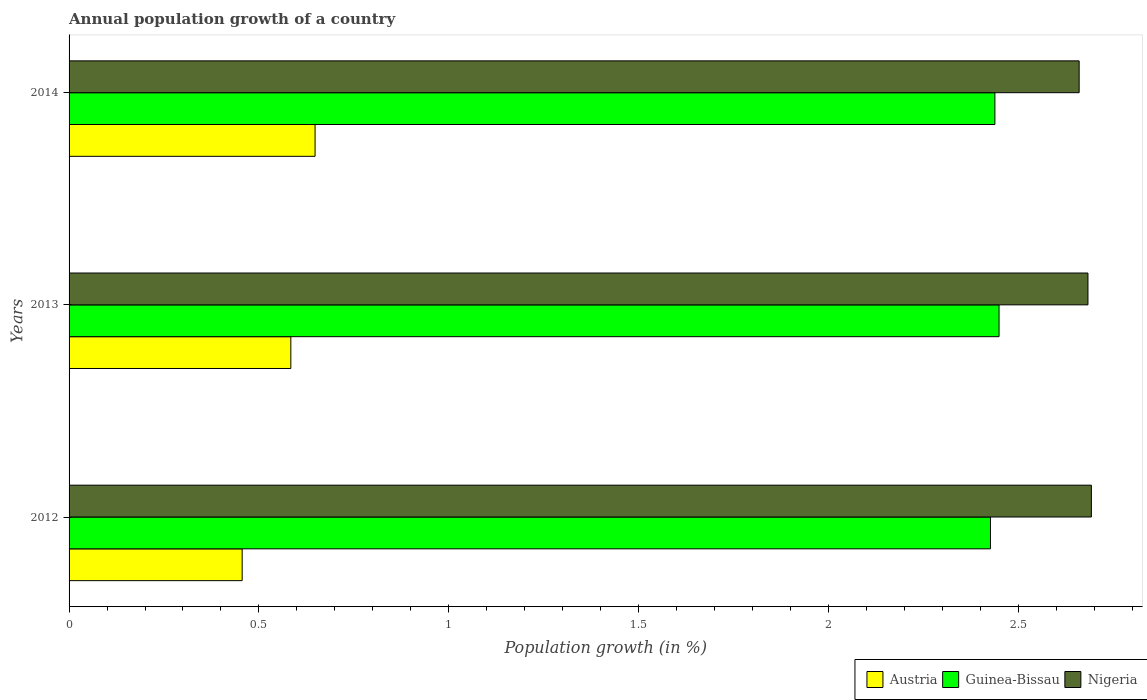How many groups of bars are there?
Keep it short and to the point. 3. In how many cases, is the number of bars for a given year not equal to the number of legend labels?
Provide a short and direct response. 0. What is the annual population growth in Austria in 2012?
Ensure brevity in your answer.  0.46. Across all years, what is the maximum annual population growth in Nigeria?
Offer a very short reply. 2.69. Across all years, what is the minimum annual population growth in Austria?
Your answer should be compact. 0.46. In which year was the annual population growth in Guinea-Bissau minimum?
Your answer should be very brief. 2012. What is the total annual population growth in Guinea-Bissau in the graph?
Your response must be concise. 7.31. What is the difference between the annual population growth in Nigeria in 2012 and that in 2013?
Your answer should be compact. 0.01. What is the difference between the annual population growth in Austria in 2014 and the annual population growth in Guinea-Bissau in 2013?
Provide a short and direct response. -1.8. What is the average annual population growth in Guinea-Bissau per year?
Keep it short and to the point. 2.44. In the year 2012, what is the difference between the annual population growth in Nigeria and annual population growth in Guinea-Bissau?
Offer a very short reply. 0.27. In how many years, is the annual population growth in Nigeria greater than 2.6 %?
Provide a short and direct response. 3. What is the ratio of the annual population growth in Austria in 2012 to that in 2014?
Give a very brief answer. 0.7. What is the difference between the highest and the second highest annual population growth in Austria?
Make the answer very short. 0.06. What is the difference between the highest and the lowest annual population growth in Nigeria?
Make the answer very short. 0.03. Is the sum of the annual population growth in Nigeria in 2013 and 2014 greater than the maximum annual population growth in Guinea-Bissau across all years?
Make the answer very short. Yes. What does the 1st bar from the top in 2012 represents?
Give a very brief answer. Nigeria. What does the 2nd bar from the bottom in 2013 represents?
Offer a very short reply. Guinea-Bissau. Is it the case that in every year, the sum of the annual population growth in Nigeria and annual population growth in Austria is greater than the annual population growth in Guinea-Bissau?
Provide a succinct answer. Yes. How many years are there in the graph?
Your answer should be very brief. 3. Are the values on the major ticks of X-axis written in scientific E-notation?
Make the answer very short. No. Does the graph contain any zero values?
Your answer should be compact. No. Where does the legend appear in the graph?
Offer a terse response. Bottom right. What is the title of the graph?
Your response must be concise. Annual population growth of a country. What is the label or title of the X-axis?
Your answer should be compact. Population growth (in %). What is the label or title of the Y-axis?
Offer a terse response. Years. What is the Population growth (in %) of Austria in 2012?
Your answer should be very brief. 0.46. What is the Population growth (in %) in Guinea-Bissau in 2012?
Offer a very short reply. 2.43. What is the Population growth (in %) in Nigeria in 2012?
Your response must be concise. 2.69. What is the Population growth (in %) of Austria in 2013?
Your answer should be very brief. 0.58. What is the Population growth (in %) in Guinea-Bissau in 2013?
Provide a succinct answer. 2.45. What is the Population growth (in %) of Nigeria in 2013?
Ensure brevity in your answer.  2.68. What is the Population growth (in %) of Austria in 2014?
Provide a succinct answer. 0.65. What is the Population growth (in %) in Guinea-Bissau in 2014?
Make the answer very short. 2.44. What is the Population growth (in %) of Nigeria in 2014?
Provide a succinct answer. 2.66. Across all years, what is the maximum Population growth (in %) of Austria?
Offer a very short reply. 0.65. Across all years, what is the maximum Population growth (in %) of Guinea-Bissau?
Your response must be concise. 2.45. Across all years, what is the maximum Population growth (in %) in Nigeria?
Keep it short and to the point. 2.69. Across all years, what is the minimum Population growth (in %) of Austria?
Offer a very short reply. 0.46. Across all years, what is the minimum Population growth (in %) in Guinea-Bissau?
Your answer should be very brief. 2.43. Across all years, what is the minimum Population growth (in %) in Nigeria?
Keep it short and to the point. 2.66. What is the total Population growth (in %) of Austria in the graph?
Give a very brief answer. 1.69. What is the total Population growth (in %) in Guinea-Bissau in the graph?
Offer a very short reply. 7.31. What is the total Population growth (in %) in Nigeria in the graph?
Give a very brief answer. 8.04. What is the difference between the Population growth (in %) of Austria in 2012 and that in 2013?
Ensure brevity in your answer.  -0.13. What is the difference between the Population growth (in %) in Guinea-Bissau in 2012 and that in 2013?
Your response must be concise. -0.02. What is the difference between the Population growth (in %) in Nigeria in 2012 and that in 2013?
Your answer should be compact. 0.01. What is the difference between the Population growth (in %) of Austria in 2012 and that in 2014?
Make the answer very short. -0.19. What is the difference between the Population growth (in %) in Guinea-Bissau in 2012 and that in 2014?
Your answer should be compact. -0.01. What is the difference between the Population growth (in %) of Nigeria in 2012 and that in 2014?
Keep it short and to the point. 0.03. What is the difference between the Population growth (in %) in Austria in 2013 and that in 2014?
Offer a terse response. -0.06. What is the difference between the Population growth (in %) in Guinea-Bissau in 2013 and that in 2014?
Keep it short and to the point. 0.01. What is the difference between the Population growth (in %) in Nigeria in 2013 and that in 2014?
Offer a terse response. 0.02. What is the difference between the Population growth (in %) in Austria in 2012 and the Population growth (in %) in Guinea-Bissau in 2013?
Your response must be concise. -1.99. What is the difference between the Population growth (in %) of Austria in 2012 and the Population growth (in %) of Nigeria in 2013?
Ensure brevity in your answer.  -2.23. What is the difference between the Population growth (in %) in Guinea-Bissau in 2012 and the Population growth (in %) in Nigeria in 2013?
Give a very brief answer. -0.26. What is the difference between the Population growth (in %) of Austria in 2012 and the Population growth (in %) of Guinea-Bissau in 2014?
Offer a very short reply. -1.98. What is the difference between the Population growth (in %) of Austria in 2012 and the Population growth (in %) of Nigeria in 2014?
Give a very brief answer. -2.2. What is the difference between the Population growth (in %) in Guinea-Bissau in 2012 and the Population growth (in %) in Nigeria in 2014?
Ensure brevity in your answer.  -0.23. What is the difference between the Population growth (in %) of Austria in 2013 and the Population growth (in %) of Guinea-Bissau in 2014?
Your response must be concise. -1.85. What is the difference between the Population growth (in %) of Austria in 2013 and the Population growth (in %) of Nigeria in 2014?
Provide a succinct answer. -2.08. What is the difference between the Population growth (in %) of Guinea-Bissau in 2013 and the Population growth (in %) of Nigeria in 2014?
Your answer should be very brief. -0.21. What is the average Population growth (in %) in Austria per year?
Make the answer very short. 0.56. What is the average Population growth (in %) in Guinea-Bissau per year?
Your answer should be very brief. 2.44. What is the average Population growth (in %) of Nigeria per year?
Give a very brief answer. 2.68. In the year 2012, what is the difference between the Population growth (in %) of Austria and Population growth (in %) of Guinea-Bissau?
Provide a short and direct response. -1.97. In the year 2012, what is the difference between the Population growth (in %) in Austria and Population growth (in %) in Nigeria?
Make the answer very short. -2.24. In the year 2012, what is the difference between the Population growth (in %) of Guinea-Bissau and Population growth (in %) of Nigeria?
Offer a terse response. -0.27. In the year 2013, what is the difference between the Population growth (in %) of Austria and Population growth (in %) of Guinea-Bissau?
Give a very brief answer. -1.87. In the year 2013, what is the difference between the Population growth (in %) of Austria and Population growth (in %) of Nigeria?
Keep it short and to the point. -2.1. In the year 2013, what is the difference between the Population growth (in %) in Guinea-Bissau and Population growth (in %) in Nigeria?
Ensure brevity in your answer.  -0.23. In the year 2014, what is the difference between the Population growth (in %) of Austria and Population growth (in %) of Guinea-Bissau?
Offer a terse response. -1.79. In the year 2014, what is the difference between the Population growth (in %) of Austria and Population growth (in %) of Nigeria?
Give a very brief answer. -2.01. In the year 2014, what is the difference between the Population growth (in %) in Guinea-Bissau and Population growth (in %) in Nigeria?
Your answer should be very brief. -0.22. What is the ratio of the Population growth (in %) in Austria in 2012 to that in 2013?
Your response must be concise. 0.78. What is the ratio of the Population growth (in %) of Austria in 2012 to that in 2014?
Provide a succinct answer. 0.7. What is the ratio of the Population growth (in %) of Guinea-Bissau in 2012 to that in 2014?
Offer a terse response. 1. What is the ratio of the Population growth (in %) in Nigeria in 2012 to that in 2014?
Provide a short and direct response. 1.01. What is the ratio of the Population growth (in %) in Austria in 2013 to that in 2014?
Provide a succinct answer. 0.9. What is the ratio of the Population growth (in %) in Guinea-Bissau in 2013 to that in 2014?
Ensure brevity in your answer.  1. What is the ratio of the Population growth (in %) in Nigeria in 2013 to that in 2014?
Give a very brief answer. 1.01. What is the difference between the highest and the second highest Population growth (in %) in Austria?
Your answer should be very brief. 0.06. What is the difference between the highest and the second highest Population growth (in %) in Guinea-Bissau?
Your answer should be compact. 0.01. What is the difference between the highest and the second highest Population growth (in %) in Nigeria?
Your answer should be compact. 0.01. What is the difference between the highest and the lowest Population growth (in %) in Austria?
Give a very brief answer. 0.19. What is the difference between the highest and the lowest Population growth (in %) of Guinea-Bissau?
Provide a succinct answer. 0.02. What is the difference between the highest and the lowest Population growth (in %) of Nigeria?
Your answer should be very brief. 0.03. 